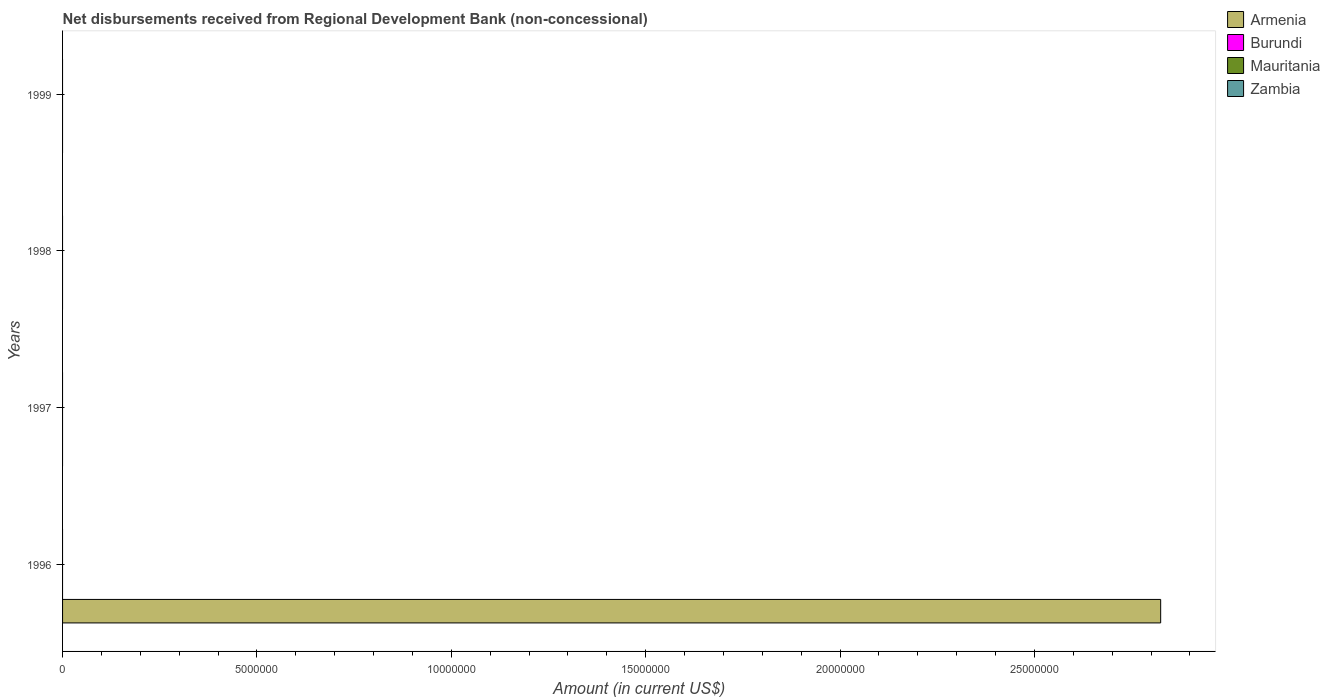Are the number of bars per tick equal to the number of legend labels?
Provide a short and direct response. No. Are the number of bars on each tick of the Y-axis equal?
Offer a terse response. No. How many bars are there on the 2nd tick from the top?
Keep it short and to the point. 0. How many bars are there on the 2nd tick from the bottom?
Offer a terse response. 0. What is the label of the 2nd group of bars from the top?
Offer a very short reply. 1998. Across all years, what is the maximum amount of disbursements received from Regional Development Bank in Armenia?
Your answer should be compact. 2.82e+07. In which year was the amount of disbursements received from Regional Development Bank in Armenia maximum?
Keep it short and to the point. 1996. What is the total amount of disbursements received from Regional Development Bank in Zambia in the graph?
Offer a very short reply. 0. What is the difference between the amount of disbursements received from Regional Development Bank in Mauritania in 1997 and the amount of disbursements received from Regional Development Bank in Armenia in 1999?
Provide a succinct answer. 0. In how many years, is the amount of disbursements received from Regional Development Bank in Armenia greater than 22000000 US$?
Offer a terse response. 1. What is the difference between the highest and the lowest amount of disbursements received from Regional Development Bank in Armenia?
Your answer should be compact. 2.82e+07. In how many years, is the amount of disbursements received from Regional Development Bank in Burundi greater than the average amount of disbursements received from Regional Development Bank in Burundi taken over all years?
Your answer should be very brief. 0. Is it the case that in every year, the sum of the amount of disbursements received from Regional Development Bank in Armenia and amount of disbursements received from Regional Development Bank in Mauritania is greater than the amount of disbursements received from Regional Development Bank in Zambia?
Your answer should be compact. No. Are all the bars in the graph horizontal?
Provide a succinct answer. Yes. What is the difference between two consecutive major ticks on the X-axis?
Your response must be concise. 5.00e+06. Are the values on the major ticks of X-axis written in scientific E-notation?
Provide a short and direct response. No. Does the graph contain any zero values?
Ensure brevity in your answer.  Yes. Does the graph contain grids?
Your answer should be compact. No. Where does the legend appear in the graph?
Offer a terse response. Top right. How many legend labels are there?
Provide a short and direct response. 4. What is the title of the graph?
Give a very brief answer. Net disbursements received from Regional Development Bank (non-concessional). Does "Ukraine" appear as one of the legend labels in the graph?
Your answer should be compact. No. What is the Amount (in current US$) of Armenia in 1996?
Provide a succinct answer. 2.82e+07. What is the Amount (in current US$) of Mauritania in 1996?
Your response must be concise. 0. What is the Amount (in current US$) in Armenia in 1997?
Offer a very short reply. 0. What is the Amount (in current US$) of Burundi in 1998?
Make the answer very short. 0. What is the Amount (in current US$) in Zambia in 1998?
Give a very brief answer. 0. What is the Amount (in current US$) of Armenia in 1999?
Offer a very short reply. 0. What is the Amount (in current US$) of Mauritania in 1999?
Your answer should be compact. 0. What is the Amount (in current US$) of Zambia in 1999?
Your answer should be compact. 0. Across all years, what is the maximum Amount (in current US$) in Armenia?
Provide a short and direct response. 2.82e+07. Across all years, what is the minimum Amount (in current US$) of Armenia?
Offer a terse response. 0. What is the total Amount (in current US$) of Armenia in the graph?
Your answer should be very brief. 2.82e+07. What is the total Amount (in current US$) in Burundi in the graph?
Give a very brief answer. 0. What is the total Amount (in current US$) of Mauritania in the graph?
Give a very brief answer. 0. What is the total Amount (in current US$) of Zambia in the graph?
Your answer should be very brief. 0. What is the average Amount (in current US$) of Armenia per year?
Offer a terse response. 7.06e+06. What is the average Amount (in current US$) of Zambia per year?
Provide a succinct answer. 0. What is the difference between the highest and the lowest Amount (in current US$) of Armenia?
Keep it short and to the point. 2.82e+07. 